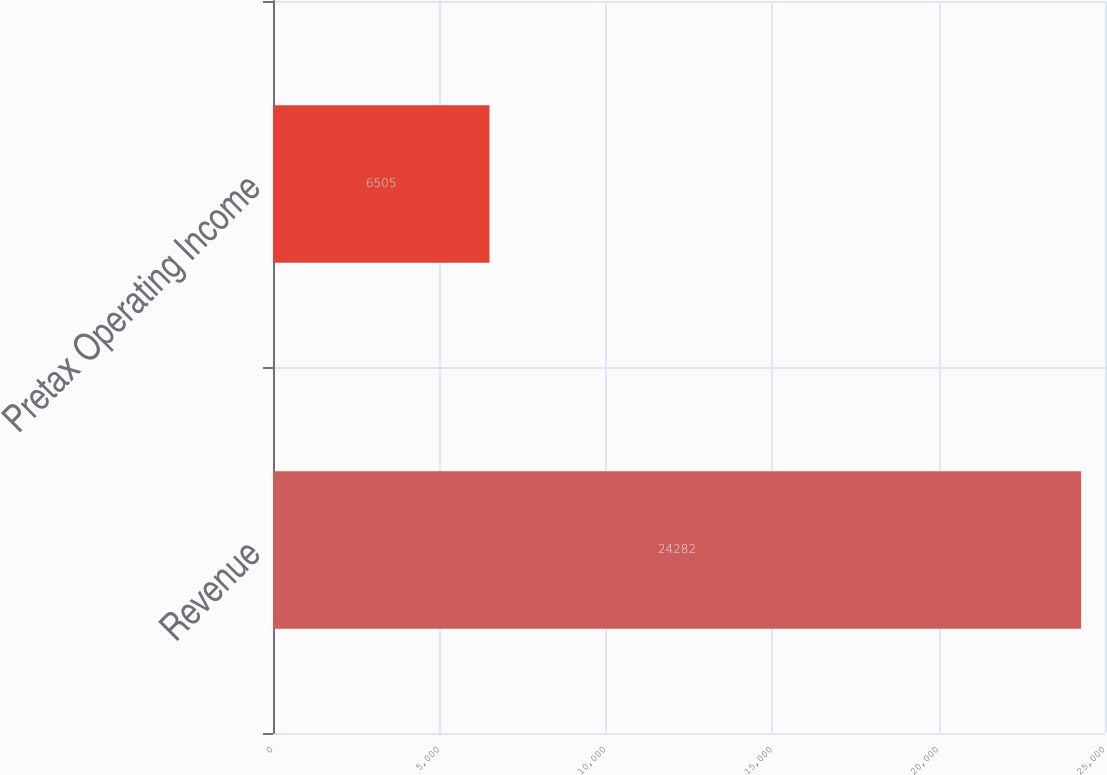Convert chart to OTSL. <chart><loc_0><loc_0><loc_500><loc_500><bar_chart><fcel>Revenue<fcel>Pretax Operating Income<nl><fcel>24282<fcel>6505<nl></chart> 